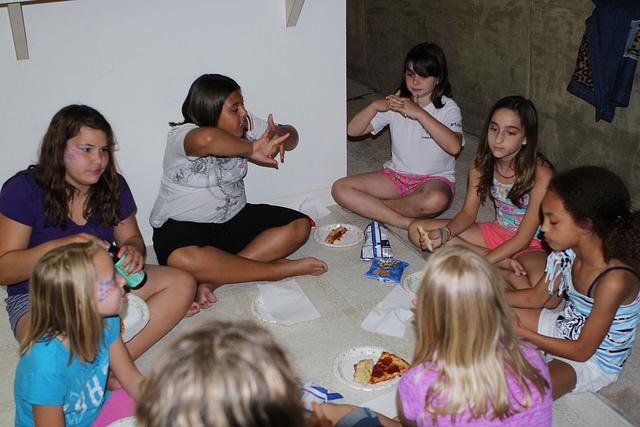How many girls are wearing pink?
Short answer required. 4. Where are the kids?
Quick response, please. On floor. What main food are they eating?
Concise answer only. Pizza. Does the woman in the middle have a kid with her?
Answer briefly. No. Do some of the girls have their face painted?
Keep it brief. Yes. 